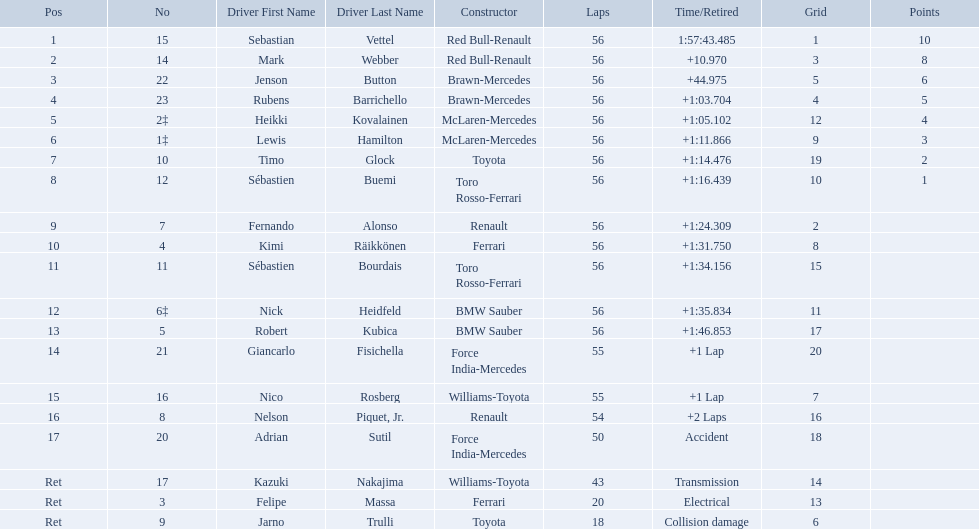Who were all the drivers? Sebastian Vettel, Mark Webber, Jenson Button, Rubens Barrichello, Heikki Kovalainen, Lewis Hamilton, Timo Glock, Sébastien Buemi, Fernando Alonso, Kimi Räikkönen, Sébastien Bourdais, Nick Heidfeld, Robert Kubica, Giancarlo Fisichella, Nico Rosberg, Nelson Piquet, Jr., Adrian Sutil, Kazuki Nakajima, Felipe Massa, Jarno Trulli. Which of these didn't have ferrari as a constructor? Sebastian Vettel, Mark Webber, Jenson Button, Rubens Barrichello, Heikki Kovalainen, Lewis Hamilton, Timo Glock, Sébastien Buemi, Fernando Alonso, Sébastien Bourdais, Nick Heidfeld, Robert Kubica, Giancarlo Fisichella, Nico Rosberg, Nelson Piquet, Jr., Adrian Sutil, Kazuki Nakajima, Jarno Trulli. Which of these was in first place? Sebastian Vettel. Which drivers raced in the 2009 chinese grand prix? Sebastian Vettel, Mark Webber, Jenson Button, Rubens Barrichello, Heikki Kovalainen, Lewis Hamilton, Timo Glock, Sébastien Buemi, Fernando Alonso, Kimi Räikkönen, Sébastien Bourdais, Nick Heidfeld, Robert Kubica, Giancarlo Fisichella, Nico Rosberg, Nelson Piquet, Jr., Adrian Sutil, Kazuki Nakajima, Felipe Massa, Jarno Trulli. Of the drivers in the 2009 chinese grand prix, which finished the race? Sebastian Vettel, Mark Webber, Jenson Button, Rubens Barrichello, Heikki Kovalainen, Lewis Hamilton, Timo Glock, Sébastien Buemi, Fernando Alonso, Kimi Räikkönen, Sébastien Bourdais, Nick Heidfeld, Robert Kubica. Of the drivers who finished the race, who had the slowest time? Robert Kubica. Who were the drivers at the 2009 chinese grand prix? Sebastian Vettel, Mark Webber, Jenson Button, Rubens Barrichello, Heikki Kovalainen, Lewis Hamilton, Timo Glock, Sébastien Buemi, Fernando Alonso, Kimi Räikkönen, Sébastien Bourdais, Nick Heidfeld, Robert Kubica, Giancarlo Fisichella, Nico Rosberg, Nelson Piquet, Jr., Adrian Sutil, Kazuki Nakajima, Felipe Massa, Jarno Trulli. Who had the slowest time? Robert Kubica. 